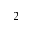Convert formula to latex. <formula><loc_0><loc_0><loc_500><loc_500>_ { 2 }</formula> 